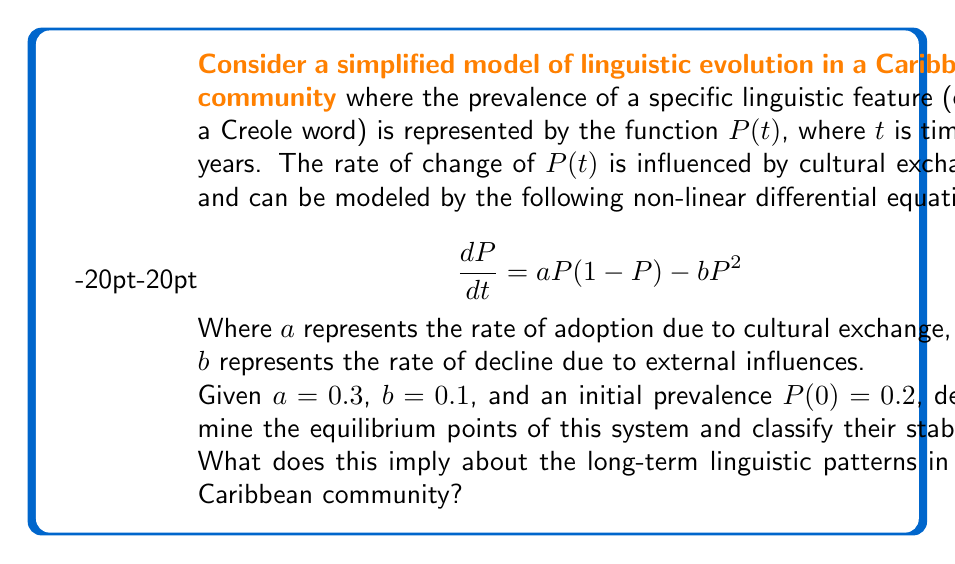Provide a solution to this math problem. To solve this problem, we'll follow these steps:

1) Find the equilibrium points by setting $\frac{dP}{dt} = 0$:

   $$0 = aP(1-P) - bP^2$$
   $$0 = 0.3P(1-P) - 0.1P^2$$
   $$0 = 0.3P - 0.3P^2 - 0.1P^2$$
   $$0 = 0.3P - 0.4P^2$$
   $$0 = P(0.3 - 0.4P)$$

   Solving this, we get:
   $P = 0$ or $P = 0.75$

2) To classify the stability of these equilibrium points, we need to find $\frac{d}{dP}(\frac{dP}{dt})$ and evaluate it at each point:

   $$\frac{d}{dP}(\frac{dP}{dt}) = a(1-2P) - 2bP$$
   $$= 0.3(1-2P) - 0.2P$$
   $$= 0.3 - 0.6P - 0.2P$$
   $$= 0.3 - 0.8P$$

3) Evaluate at $P = 0$:
   $0.3 - 0.8(0) = 0.3 > 0$, so this is an unstable equilibrium.

4) Evaluate at $P = 0.75$:
   $0.3 - 0.8(0.75) = -0.3 < 0$, so this is a stable equilibrium.

5) Interpretation: The model predicts that the linguistic feature will naturally tend towards a prevalence of 75% in the long term, regardless of its initial prevalence (as long as it's not exactly 0). This suggests a strong tendency for this feature to persist and become dominant in the community's linguistic patterns over time.
Answer: Two equilibrium points: $P = 0$ (unstable) and $P = 0.75$ (stable). Long-term prevalence tends to 75%. 